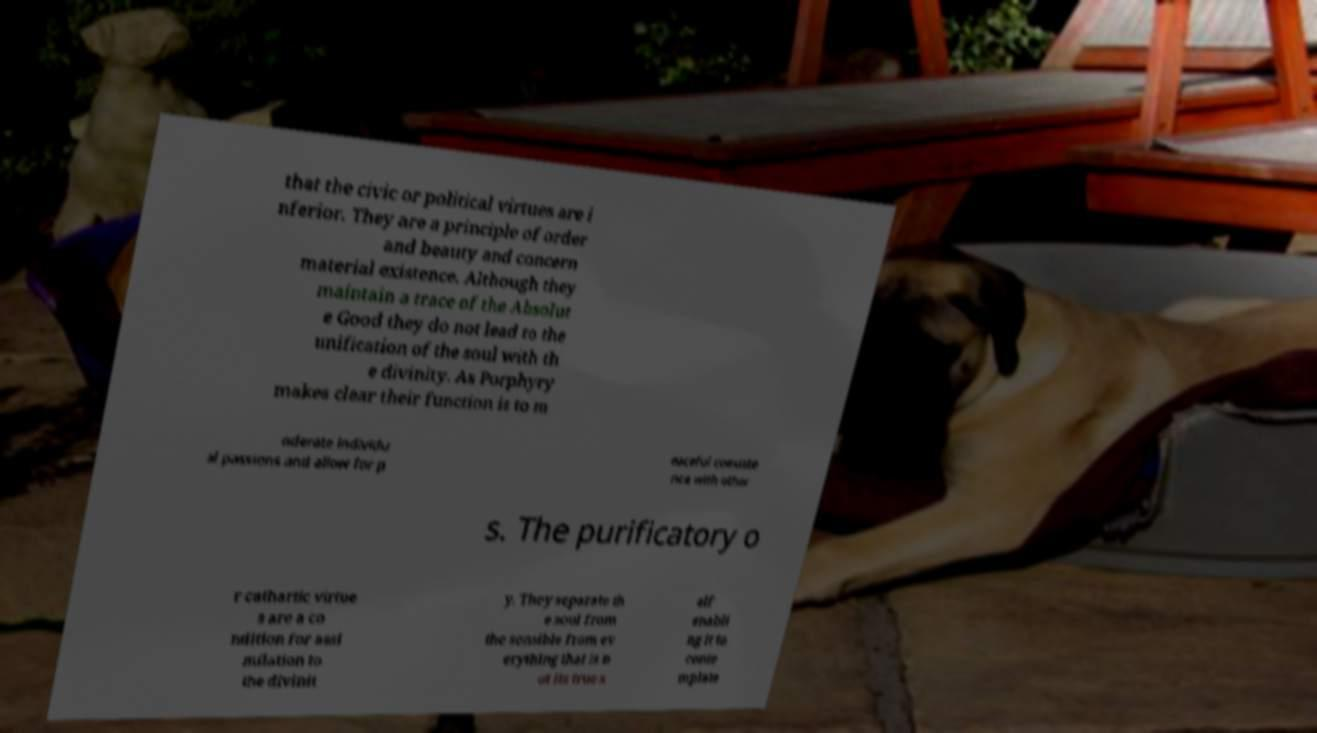Could you extract and type out the text from this image? that the civic or political virtues are i nferior. They are a principle of order and beauty and concern material existence. Although they maintain a trace of the Absolut e Good they do not lead to the unification of the soul with th e divinity. As Porphyry makes clear their function is to m oderate individu al passions and allow for p eaceful coexiste nce with other s. The purificatory o r cathartic virtue s are a co ndition for assi milation to the divinit y. They separate th e soul from the sensible from ev erything that is n ot its true s elf enabli ng it to conte mplate 